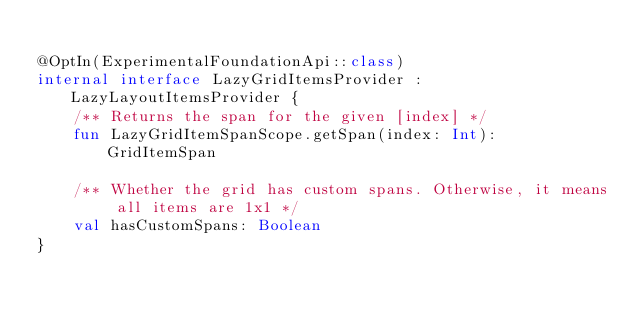<code> <loc_0><loc_0><loc_500><loc_500><_Kotlin_>
@OptIn(ExperimentalFoundationApi::class)
internal interface LazyGridItemsProvider : LazyLayoutItemsProvider {
    /** Returns the span for the given [index] */
    fun LazyGridItemSpanScope.getSpan(index: Int): GridItemSpan

    /** Whether the grid has custom spans. Otherwise, it means all items are 1x1 */
    val hasCustomSpans: Boolean
}
</code> 